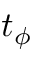<formula> <loc_0><loc_0><loc_500><loc_500>t _ { \phi }</formula> 